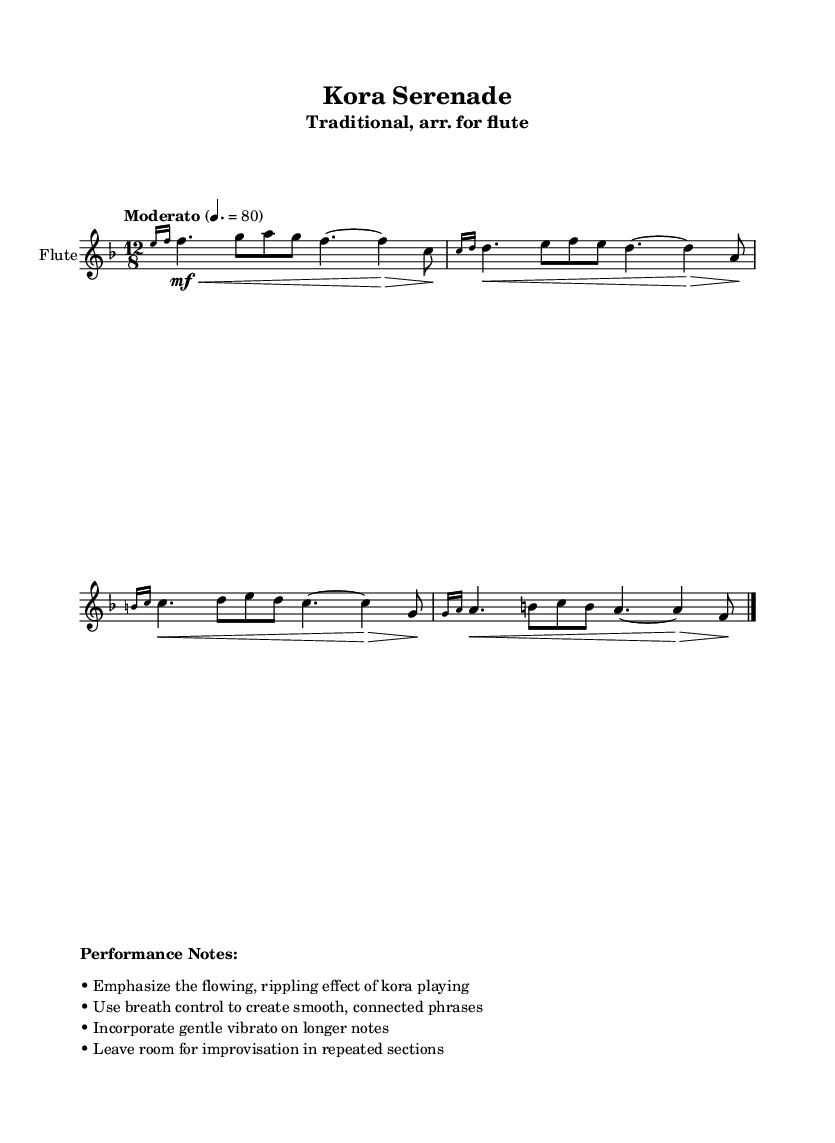What is the key signature of this music? The key signature is F major, which has one flat (B flat).
Answer: F major What is the time signature of this music? The time signature is 12/8, meaning there are 12 eighth notes in each measure.
Answer: 12/8 What is the indicated tempo for this piece? The tempo marking is "Moderato," specifying a moderate speed of 80 beats per minute.
Answer: Moderato, 80 How many measures are in the piece? There is one measure visible in the sheet music portion provided.
Answer: One What performance technique is emphasized in this piece? The performance notes emphasize a flowing, rippling effect, typical of kora playing.
Answer: Flowing, rippling effect Why is breath control important in this piece? Breath control is needed to create smooth and connected phrases, enhancing the lyrical quality of the music.
Answer: Smooth, connected phrases What should be left room for in repeated sections? The performance notes indicate room for improvisation in repeated sections, allowing for personal expression.
Answer: Improvisation 